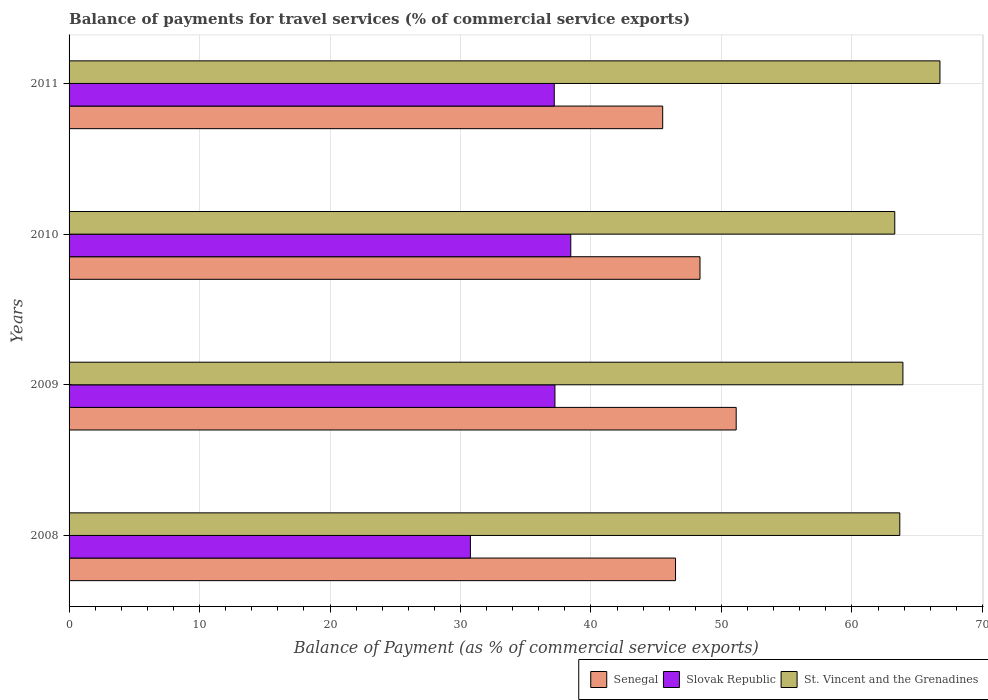Are the number of bars per tick equal to the number of legend labels?
Keep it short and to the point. Yes. What is the label of the 4th group of bars from the top?
Your answer should be very brief. 2008. What is the balance of payments for travel services in Slovak Republic in 2009?
Provide a short and direct response. 37.24. Across all years, what is the maximum balance of payments for travel services in St. Vincent and the Grenadines?
Your response must be concise. 66.75. Across all years, what is the minimum balance of payments for travel services in Slovak Republic?
Keep it short and to the point. 30.76. In which year was the balance of payments for travel services in St. Vincent and the Grenadines maximum?
Your answer should be compact. 2011. In which year was the balance of payments for travel services in Slovak Republic minimum?
Give a very brief answer. 2008. What is the total balance of payments for travel services in Slovak Republic in the graph?
Give a very brief answer. 143.64. What is the difference between the balance of payments for travel services in St. Vincent and the Grenadines in 2009 and that in 2011?
Provide a short and direct response. -2.84. What is the difference between the balance of payments for travel services in Senegal in 2009 and the balance of payments for travel services in Slovak Republic in 2008?
Your response must be concise. 20.37. What is the average balance of payments for travel services in Slovak Republic per year?
Keep it short and to the point. 35.91. In the year 2008, what is the difference between the balance of payments for travel services in Slovak Republic and balance of payments for travel services in St. Vincent and the Grenadines?
Give a very brief answer. -32.91. What is the ratio of the balance of payments for travel services in St. Vincent and the Grenadines in 2010 to that in 2011?
Ensure brevity in your answer.  0.95. What is the difference between the highest and the second highest balance of payments for travel services in Slovak Republic?
Provide a short and direct response. 1.21. What is the difference between the highest and the lowest balance of payments for travel services in Slovak Republic?
Offer a terse response. 7.69. What does the 3rd bar from the top in 2010 represents?
Provide a succinct answer. Senegal. What does the 1st bar from the bottom in 2010 represents?
Your answer should be compact. Senegal. Is it the case that in every year, the sum of the balance of payments for travel services in Slovak Republic and balance of payments for travel services in St. Vincent and the Grenadines is greater than the balance of payments for travel services in Senegal?
Provide a succinct answer. Yes. Are all the bars in the graph horizontal?
Ensure brevity in your answer.  Yes. How many years are there in the graph?
Offer a terse response. 4. Are the values on the major ticks of X-axis written in scientific E-notation?
Make the answer very short. No. Where does the legend appear in the graph?
Your response must be concise. Bottom right. How many legend labels are there?
Offer a very short reply. 3. How are the legend labels stacked?
Provide a succinct answer. Horizontal. What is the title of the graph?
Ensure brevity in your answer.  Balance of payments for travel services (% of commercial service exports). What is the label or title of the X-axis?
Ensure brevity in your answer.  Balance of Payment (as % of commercial service exports). What is the Balance of Payment (as % of commercial service exports) of Senegal in 2008?
Provide a short and direct response. 46.48. What is the Balance of Payment (as % of commercial service exports) of Slovak Republic in 2008?
Provide a short and direct response. 30.76. What is the Balance of Payment (as % of commercial service exports) of St. Vincent and the Grenadines in 2008?
Ensure brevity in your answer.  63.67. What is the Balance of Payment (as % of commercial service exports) in Senegal in 2009?
Make the answer very short. 51.13. What is the Balance of Payment (as % of commercial service exports) of Slovak Republic in 2009?
Ensure brevity in your answer.  37.24. What is the Balance of Payment (as % of commercial service exports) in St. Vincent and the Grenadines in 2009?
Provide a succinct answer. 63.91. What is the Balance of Payment (as % of commercial service exports) of Senegal in 2010?
Provide a succinct answer. 48.36. What is the Balance of Payment (as % of commercial service exports) in Slovak Republic in 2010?
Provide a short and direct response. 38.45. What is the Balance of Payment (as % of commercial service exports) of St. Vincent and the Grenadines in 2010?
Give a very brief answer. 63.28. What is the Balance of Payment (as % of commercial service exports) of Senegal in 2011?
Your answer should be very brief. 45.5. What is the Balance of Payment (as % of commercial service exports) in Slovak Republic in 2011?
Your answer should be very brief. 37.19. What is the Balance of Payment (as % of commercial service exports) in St. Vincent and the Grenadines in 2011?
Offer a terse response. 66.75. Across all years, what is the maximum Balance of Payment (as % of commercial service exports) in Senegal?
Your response must be concise. 51.13. Across all years, what is the maximum Balance of Payment (as % of commercial service exports) of Slovak Republic?
Make the answer very short. 38.45. Across all years, what is the maximum Balance of Payment (as % of commercial service exports) in St. Vincent and the Grenadines?
Provide a succinct answer. 66.75. Across all years, what is the minimum Balance of Payment (as % of commercial service exports) in Senegal?
Provide a short and direct response. 45.5. Across all years, what is the minimum Balance of Payment (as % of commercial service exports) of Slovak Republic?
Provide a succinct answer. 30.76. Across all years, what is the minimum Balance of Payment (as % of commercial service exports) of St. Vincent and the Grenadines?
Give a very brief answer. 63.28. What is the total Balance of Payment (as % of commercial service exports) of Senegal in the graph?
Ensure brevity in your answer.  191.46. What is the total Balance of Payment (as % of commercial service exports) of Slovak Republic in the graph?
Your answer should be very brief. 143.64. What is the total Balance of Payment (as % of commercial service exports) in St. Vincent and the Grenadines in the graph?
Provide a short and direct response. 257.61. What is the difference between the Balance of Payment (as % of commercial service exports) of Senegal in 2008 and that in 2009?
Ensure brevity in your answer.  -4.65. What is the difference between the Balance of Payment (as % of commercial service exports) of Slovak Republic in 2008 and that in 2009?
Make the answer very short. -6.48. What is the difference between the Balance of Payment (as % of commercial service exports) in St. Vincent and the Grenadines in 2008 and that in 2009?
Offer a very short reply. -0.24. What is the difference between the Balance of Payment (as % of commercial service exports) of Senegal in 2008 and that in 2010?
Provide a short and direct response. -1.88. What is the difference between the Balance of Payment (as % of commercial service exports) of Slovak Republic in 2008 and that in 2010?
Ensure brevity in your answer.  -7.69. What is the difference between the Balance of Payment (as % of commercial service exports) of St. Vincent and the Grenadines in 2008 and that in 2010?
Provide a short and direct response. 0.39. What is the difference between the Balance of Payment (as % of commercial service exports) in Senegal in 2008 and that in 2011?
Your answer should be very brief. 0.98. What is the difference between the Balance of Payment (as % of commercial service exports) of Slovak Republic in 2008 and that in 2011?
Offer a terse response. -6.43. What is the difference between the Balance of Payment (as % of commercial service exports) of St. Vincent and the Grenadines in 2008 and that in 2011?
Your response must be concise. -3.08. What is the difference between the Balance of Payment (as % of commercial service exports) of Senegal in 2009 and that in 2010?
Give a very brief answer. 2.77. What is the difference between the Balance of Payment (as % of commercial service exports) of Slovak Republic in 2009 and that in 2010?
Give a very brief answer. -1.21. What is the difference between the Balance of Payment (as % of commercial service exports) of St. Vincent and the Grenadines in 2009 and that in 2010?
Give a very brief answer. 0.62. What is the difference between the Balance of Payment (as % of commercial service exports) of Senegal in 2009 and that in 2011?
Give a very brief answer. 5.63. What is the difference between the Balance of Payment (as % of commercial service exports) in Slovak Republic in 2009 and that in 2011?
Provide a short and direct response. 0.05. What is the difference between the Balance of Payment (as % of commercial service exports) in St. Vincent and the Grenadines in 2009 and that in 2011?
Ensure brevity in your answer.  -2.84. What is the difference between the Balance of Payment (as % of commercial service exports) of Senegal in 2010 and that in 2011?
Your response must be concise. 2.86. What is the difference between the Balance of Payment (as % of commercial service exports) in Slovak Republic in 2010 and that in 2011?
Make the answer very short. 1.26. What is the difference between the Balance of Payment (as % of commercial service exports) of St. Vincent and the Grenadines in 2010 and that in 2011?
Make the answer very short. -3.46. What is the difference between the Balance of Payment (as % of commercial service exports) in Senegal in 2008 and the Balance of Payment (as % of commercial service exports) in Slovak Republic in 2009?
Your answer should be compact. 9.24. What is the difference between the Balance of Payment (as % of commercial service exports) of Senegal in 2008 and the Balance of Payment (as % of commercial service exports) of St. Vincent and the Grenadines in 2009?
Give a very brief answer. -17.43. What is the difference between the Balance of Payment (as % of commercial service exports) of Slovak Republic in 2008 and the Balance of Payment (as % of commercial service exports) of St. Vincent and the Grenadines in 2009?
Keep it short and to the point. -33.15. What is the difference between the Balance of Payment (as % of commercial service exports) of Senegal in 2008 and the Balance of Payment (as % of commercial service exports) of Slovak Republic in 2010?
Your response must be concise. 8.03. What is the difference between the Balance of Payment (as % of commercial service exports) in Senegal in 2008 and the Balance of Payment (as % of commercial service exports) in St. Vincent and the Grenadines in 2010?
Your answer should be compact. -16.8. What is the difference between the Balance of Payment (as % of commercial service exports) in Slovak Republic in 2008 and the Balance of Payment (as % of commercial service exports) in St. Vincent and the Grenadines in 2010?
Ensure brevity in your answer.  -32.52. What is the difference between the Balance of Payment (as % of commercial service exports) of Senegal in 2008 and the Balance of Payment (as % of commercial service exports) of Slovak Republic in 2011?
Provide a succinct answer. 9.29. What is the difference between the Balance of Payment (as % of commercial service exports) of Senegal in 2008 and the Balance of Payment (as % of commercial service exports) of St. Vincent and the Grenadines in 2011?
Your answer should be compact. -20.27. What is the difference between the Balance of Payment (as % of commercial service exports) in Slovak Republic in 2008 and the Balance of Payment (as % of commercial service exports) in St. Vincent and the Grenadines in 2011?
Give a very brief answer. -35.99. What is the difference between the Balance of Payment (as % of commercial service exports) in Senegal in 2009 and the Balance of Payment (as % of commercial service exports) in Slovak Republic in 2010?
Offer a terse response. 12.68. What is the difference between the Balance of Payment (as % of commercial service exports) of Senegal in 2009 and the Balance of Payment (as % of commercial service exports) of St. Vincent and the Grenadines in 2010?
Keep it short and to the point. -12.15. What is the difference between the Balance of Payment (as % of commercial service exports) in Slovak Republic in 2009 and the Balance of Payment (as % of commercial service exports) in St. Vincent and the Grenadines in 2010?
Offer a very short reply. -26.04. What is the difference between the Balance of Payment (as % of commercial service exports) of Senegal in 2009 and the Balance of Payment (as % of commercial service exports) of Slovak Republic in 2011?
Your response must be concise. 13.94. What is the difference between the Balance of Payment (as % of commercial service exports) in Senegal in 2009 and the Balance of Payment (as % of commercial service exports) in St. Vincent and the Grenadines in 2011?
Offer a very short reply. -15.62. What is the difference between the Balance of Payment (as % of commercial service exports) of Slovak Republic in 2009 and the Balance of Payment (as % of commercial service exports) of St. Vincent and the Grenadines in 2011?
Provide a succinct answer. -29.51. What is the difference between the Balance of Payment (as % of commercial service exports) of Senegal in 2010 and the Balance of Payment (as % of commercial service exports) of Slovak Republic in 2011?
Provide a short and direct response. 11.17. What is the difference between the Balance of Payment (as % of commercial service exports) of Senegal in 2010 and the Balance of Payment (as % of commercial service exports) of St. Vincent and the Grenadines in 2011?
Provide a short and direct response. -18.39. What is the difference between the Balance of Payment (as % of commercial service exports) in Slovak Republic in 2010 and the Balance of Payment (as % of commercial service exports) in St. Vincent and the Grenadines in 2011?
Offer a very short reply. -28.3. What is the average Balance of Payment (as % of commercial service exports) of Senegal per year?
Keep it short and to the point. 47.87. What is the average Balance of Payment (as % of commercial service exports) of Slovak Republic per year?
Your response must be concise. 35.91. What is the average Balance of Payment (as % of commercial service exports) of St. Vincent and the Grenadines per year?
Ensure brevity in your answer.  64.4. In the year 2008, what is the difference between the Balance of Payment (as % of commercial service exports) of Senegal and Balance of Payment (as % of commercial service exports) of Slovak Republic?
Your answer should be very brief. 15.72. In the year 2008, what is the difference between the Balance of Payment (as % of commercial service exports) in Senegal and Balance of Payment (as % of commercial service exports) in St. Vincent and the Grenadines?
Give a very brief answer. -17.19. In the year 2008, what is the difference between the Balance of Payment (as % of commercial service exports) in Slovak Republic and Balance of Payment (as % of commercial service exports) in St. Vincent and the Grenadines?
Offer a terse response. -32.91. In the year 2009, what is the difference between the Balance of Payment (as % of commercial service exports) in Senegal and Balance of Payment (as % of commercial service exports) in Slovak Republic?
Provide a succinct answer. 13.89. In the year 2009, what is the difference between the Balance of Payment (as % of commercial service exports) of Senegal and Balance of Payment (as % of commercial service exports) of St. Vincent and the Grenadines?
Make the answer very short. -12.78. In the year 2009, what is the difference between the Balance of Payment (as % of commercial service exports) of Slovak Republic and Balance of Payment (as % of commercial service exports) of St. Vincent and the Grenadines?
Give a very brief answer. -26.67. In the year 2010, what is the difference between the Balance of Payment (as % of commercial service exports) in Senegal and Balance of Payment (as % of commercial service exports) in Slovak Republic?
Your answer should be compact. 9.91. In the year 2010, what is the difference between the Balance of Payment (as % of commercial service exports) of Senegal and Balance of Payment (as % of commercial service exports) of St. Vincent and the Grenadines?
Give a very brief answer. -14.93. In the year 2010, what is the difference between the Balance of Payment (as % of commercial service exports) in Slovak Republic and Balance of Payment (as % of commercial service exports) in St. Vincent and the Grenadines?
Your answer should be compact. -24.83. In the year 2011, what is the difference between the Balance of Payment (as % of commercial service exports) in Senegal and Balance of Payment (as % of commercial service exports) in Slovak Republic?
Provide a succinct answer. 8.31. In the year 2011, what is the difference between the Balance of Payment (as % of commercial service exports) of Senegal and Balance of Payment (as % of commercial service exports) of St. Vincent and the Grenadines?
Give a very brief answer. -21.25. In the year 2011, what is the difference between the Balance of Payment (as % of commercial service exports) of Slovak Republic and Balance of Payment (as % of commercial service exports) of St. Vincent and the Grenadines?
Provide a succinct answer. -29.56. What is the ratio of the Balance of Payment (as % of commercial service exports) in Slovak Republic in 2008 to that in 2009?
Offer a very short reply. 0.83. What is the ratio of the Balance of Payment (as % of commercial service exports) in St. Vincent and the Grenadines in 2008 to that in 2009?
Your answer should be very brief. 1. What is the ratio of the Balance of Payment (as % of commercial service exports) in Senegal in 2008 to that in 2010?
Offer a terse response. 0.96. What is the ratio of the Balance of Payment (as % of commercial service exports) of St. Vincent and the Grenadines in 2008 to that in 2010?
Provide a short and direct response. 1.01. What is the ratio of the Balance of Payment (as % of commercial service exports) of Senegal in 2008 to that in 2011?
Keep it short and to the point. 1.02. What is the ratio of the Balance of Payment (as % of commercial service exports) of Slovak Republic in 2008 to that in 2011?
Provide a short and direct response. 0.83. What is the ratio of the Balance of Payment (as % of commercial service exports) of St. Vincent and the Grenadines in 2008 to that in 2011?
Offer a terse response. 0.95. What is the ratio of the Balance of Payment (as % of commercial service exports) in Senegal in 2009 to that in 2010?
Make the answer very short. 1.06. What is the ratio of the Balance of Payment (as % of commercial service exports) of Slovak Republic in 2009 to that in 2010?
Provide a succinct answer. 0.97. What is the ratio of the Balance of Payment (as % of commercial service exports) in St. Vincent and the Grenadines in 2009 to that in 2010?
Provide a succinct answer. 1.01. What is the ratio of the Balance of Payment (as % of commercial service exports) in Senegal in 2009 to that in 2011?
Keep it short and to the point. 1.12. What is the ratio of the Balance of Payment (as % of commercial service exports) in St. Vincent and the Grenadines in 2009 to that in 2011?
Provide a short and direct response. 0.96. What is the ratio of the Balance of Payment (as % of commercial service exports) in Senegal in 2010 to that in 2011?
Ensure brevity in your answer.  1.06. What is the ratio of the Balance of Payment (as % of commercial service exports) in Slovak Republic in 2010 to that in 2011?
Keep it short and to the point. 1.03. What is the ratio of the Balance of Payment (as % of commercial service exports) of St. Vincent and the Grenadines in 2010 to that in 2011?
Keep it short and to the point. 0.95. What is the difference between the highest and the second highest Balance of Payment (as % of commercial service exports) of Senegal?
Your response must be concise. 2.77. What is the difference between the highest and the second highest Balance of Payment (as % of commercial service exports) of Slovak Republic?
Offer a very short reply. 1.21. What is the difference between the highest and the second highest Balance of Payment (as % of commercial service exports) of St. Vincent and the Grenadines?
Ensure brevity in your answer.  2.84. What is the difference between the highest and the lowest Balance of Payment (as % of commercial service exports) in Senegal?
Offer a terse response. 5.63. What is the difference between the highest and the lowest Balance of Payment (as % of commercial service exports) of Slovak Republic?
Your answer should be compact. 7.69. What is the difference between the highest and the lowest Balance of Payment (as % of commercial service exports) in St. Vincent and the Grenadines?
Keep it short and to the point. 3.46. 